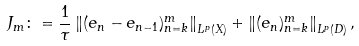Convert formula to latex. <formula><loc_0><loc_0><loc_500><loc_500>J _ { m } \colon = \frac { 1 } { \tau } \left \| ( e _ { n } - e _ { n - 1 } ) _ { n = k } ^ { m } \right \| _ { L ^ { p } ( X ) } + \left \| ( e _ { n } ) _ { n = k } ^ { m } \right \| _ { L ^ { p } ( D ) } ,</formula> 